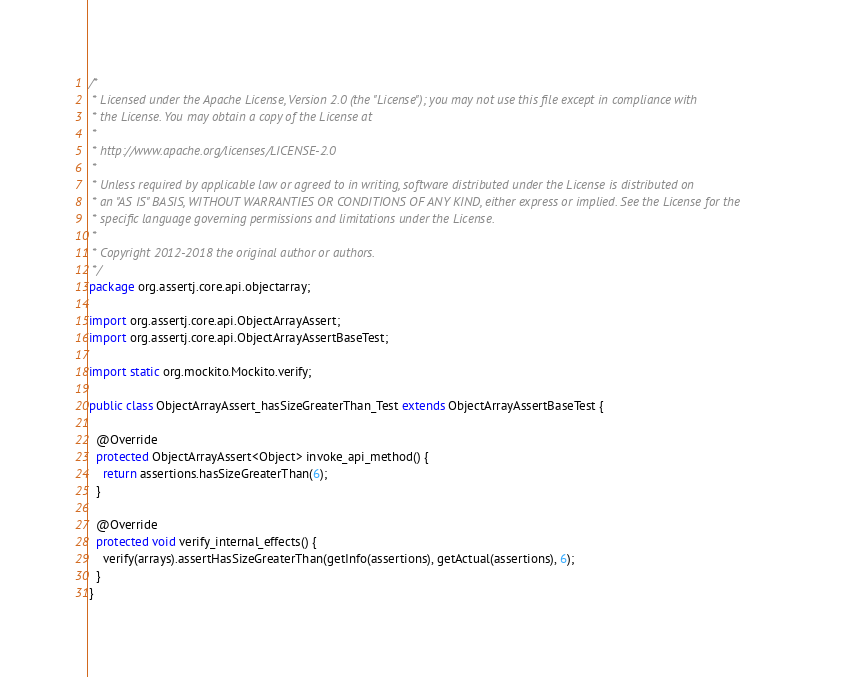<code> <loc_0><loc_0><loc_500><loc_500><_Java_>/*
 * Licensed under the Apache License, Version 2.0 (the "License"); you may not use this file except in compliance with
 * the License. You may obtain a copy of the License at
 *
 * http://www.apache.org/licenses/LICENSE-2.0
 *
 * Unless required by applicable law or agreed to in writing, software distributed under the License is distributed on
 * an "AS IS" BASIS, WITHOUT WARRANTIES OR CONDITIONS OF ANY KIND, either express or implied. See the License for the
 * specific language governing permissions and limitations under the License.
 *
 * Copyright 2012-2018 the original author or authors.
 */
package org.assertj.core.api.objectarray;

import org.assertj.core.api.ObjectArrayAssert;
import org.assertj.core.api.ObjectArrayAssertBaseTest;

import static org.mockito.Mockito.verify;

public class ObjectArrayAssert_hasSizeGreaterThan_Test extends ObjectArrayAssertBaseTest {

  @Override
  protected ObjectArrayAssert<Object> invoke_api_method() {
    return assertions.hasSizeGreaterThan(6);
  }

  @Override
  protected void verify_internal_effects() {
    verify(arrays).assertHasSizeGreaterThan(getInfo(assertions), getActual(assertions), 6);
  }
}
</code> 